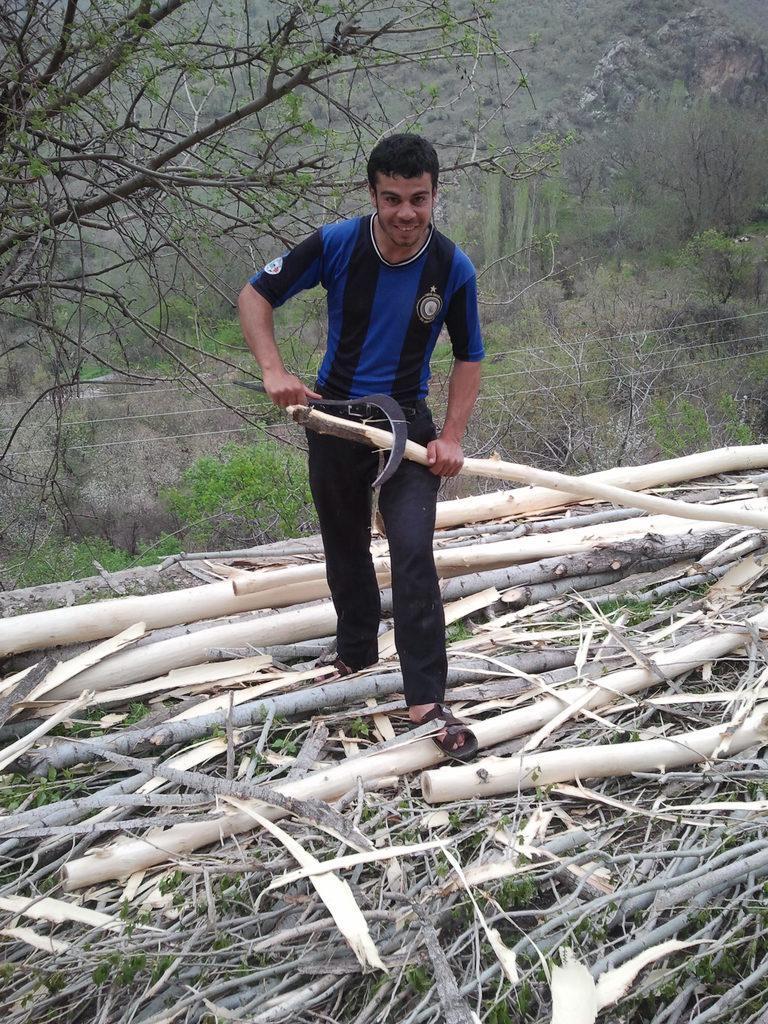Can you describe this image briefly? In this image we can see a person holding a sickle and a wood pole in his hands. At the bottom of the image we can see some wooden sticks and some poles. In the background, we can see some plants, cables and some trees. 